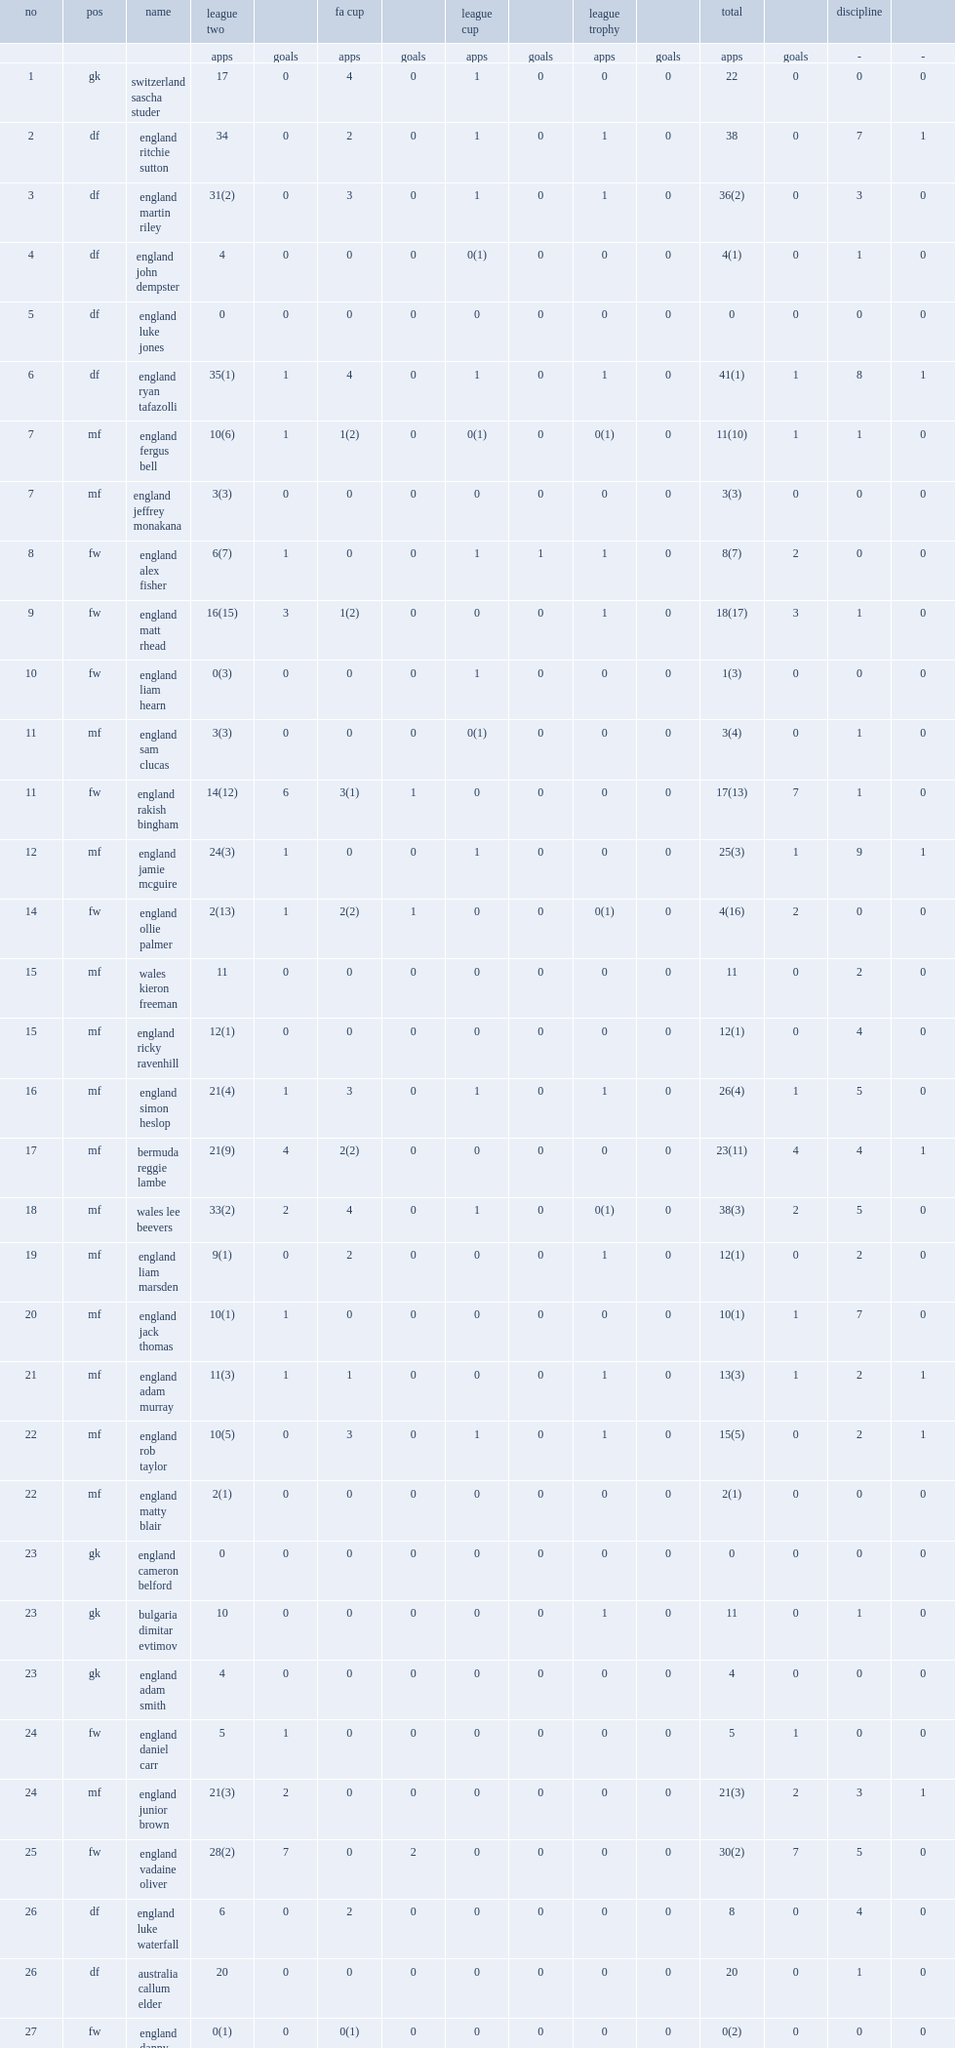What the matches did the mansfield town f.c. take part in? Fa cup league cup league trophy. 